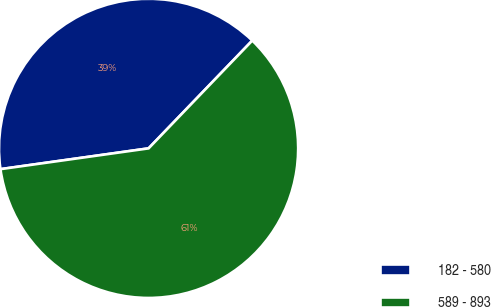Convert chart to OTSL. <chart><loc_0><loc_0><loc_500><loc_500><pie_chart><fcel>182 - 580<fcel>589 - 893<nl><fcel>39.41%<fcel>60.59%<nl></chart> 